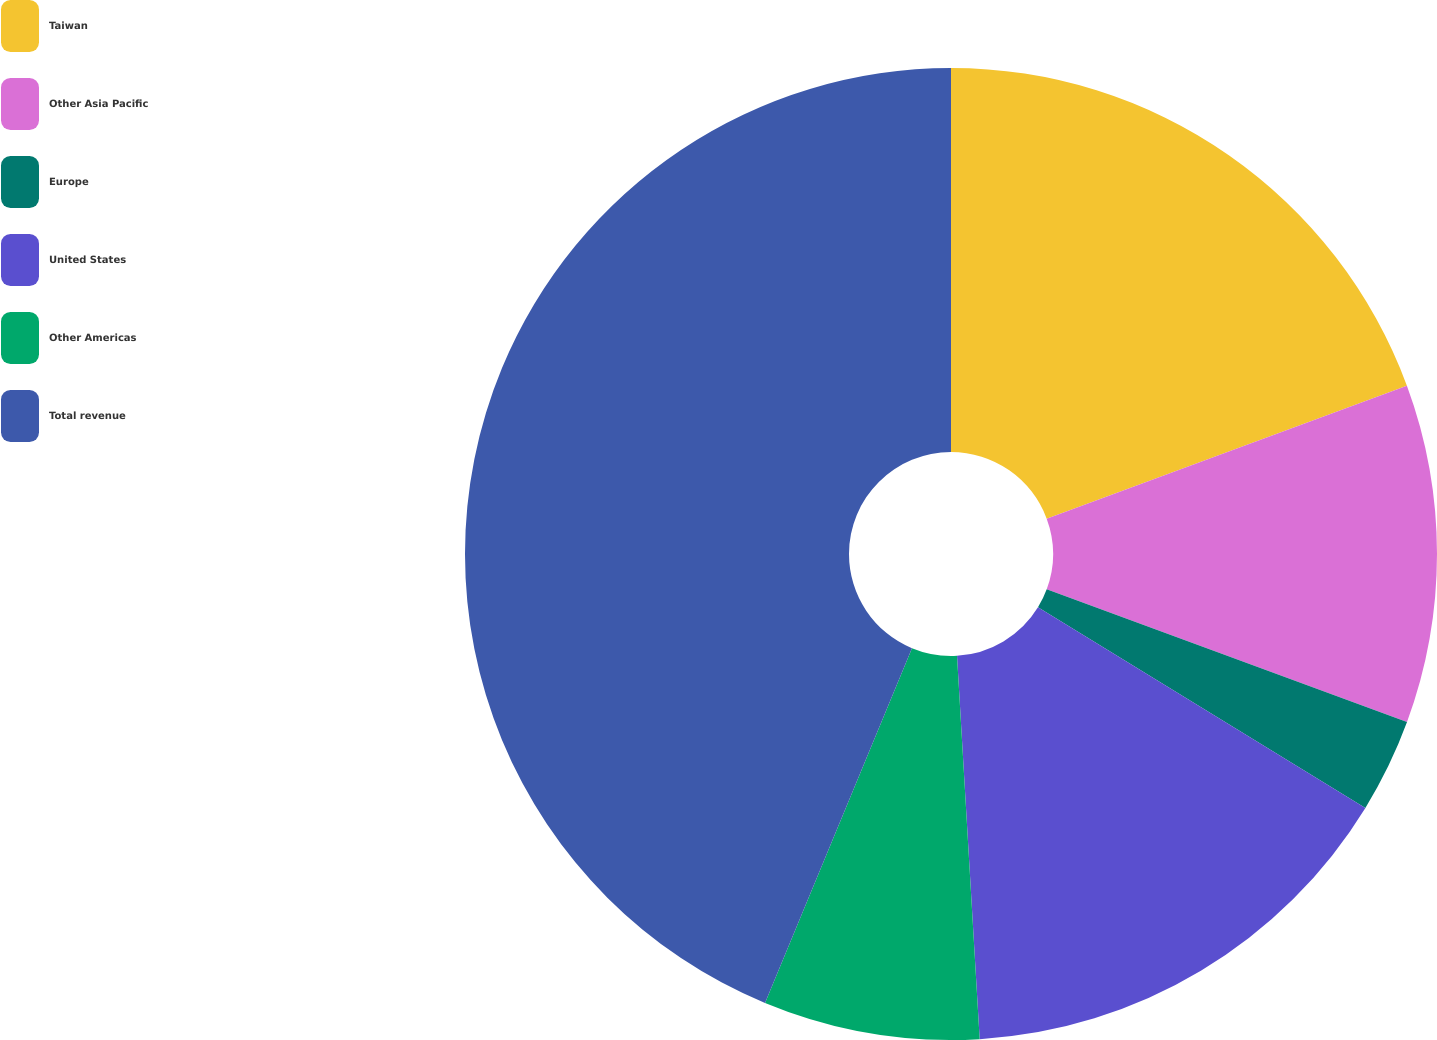Convert chart. <chart><loc_0><loc_0><loc_500><loc_500><pie_chart><fcel>Taiwan<fcel>Other Asia Pacific<fcel>Europe<fcel>United States<fcel>Other Americas<fcel>Total revenue<nl><fcel>19.37%<fcel>11.25%<fcel>3.13%<fcel>15.31%<fcel>7.19%<fcel>43.75%<nl></chart> 